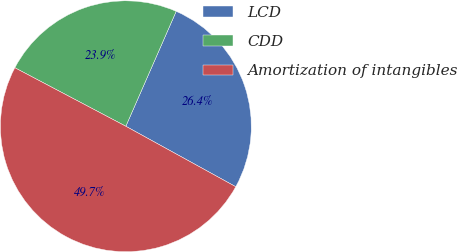Convert chart to OTSL. <chart><loc_0><loc_0><loc_500><loc_500><pie_chart><fcel>LCD<fcel>CDD<fcel>Amortization of intangibles<nl><fcel>26.43%<fcel>23.85%<fcel>49.72%<nl></chart> 